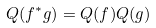Convert formula to latex. <formula><loc_0><loc_0><loc_500><loc_500>Q ( f ^ { * } g ) = Q ( f ) Q ( g )</formula> 